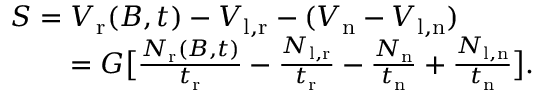<formula> <loc_0><loc_0><loc_500><loc_500>\begin{array} { r l } { S = V _ { r } ( B , t ) - V _ { l , r } - ( V _ { n } - V _ { l , n } ) } \\ { = G \left [ \frac { N _ { r } ( B , t ) } { t _ { r } } - \frac { N _ { l , r } } { t _ { r } } - \frac { N _ { n } } { t _ { n } } + \frac { N _ { l , n } } { t _ { n } } \right ] . } \end{array}</formula> 